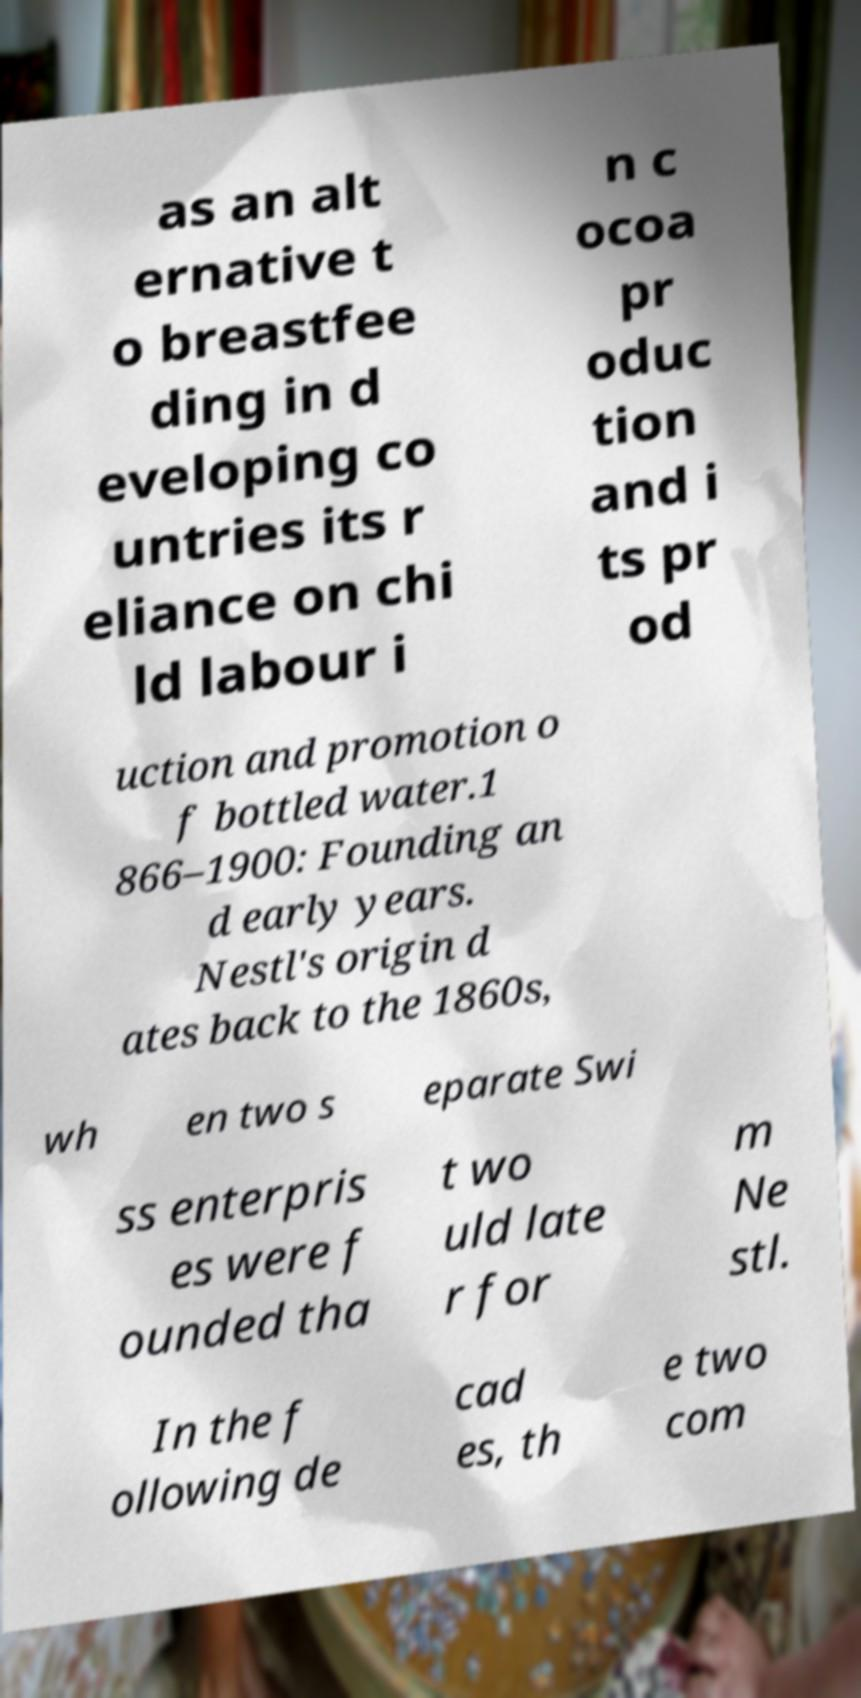I need the written content from this picture converted into text. Can you do that? as an alt ernative t o breastfee ding in d eveloping co untries its r eliance on chi ld labour i n c ocoa pr oduc tion and i ts pr od uction and promotion o f bottled water.1 866–1900: Founding an d early years. Nestl's origin d ates back to the 1860s, wh en two s eparate Swi ss enterpris es were f ounded tha t wo uld late r for m Ne stl. In the f ollowing de cad es, th e two com 